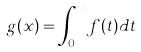Convert formula to latex. <formula><loc_0><loc_0><loc_500><loc_500>g ( x ) = \int _ { 0 } ^ { x } f ( t ) d t</formula> 